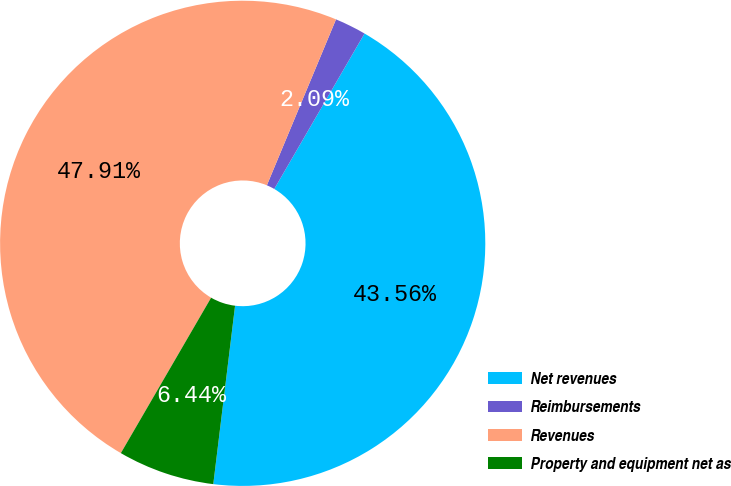<chart> <loc_0><loc_0><loc_500><loc_500><pie_chart><fcel>Net revenues<fcel>Reimbursements<fcel>Revenues<fcel>Property and equipment net as<nl><fcel>43.56%<fcel>2.09%<fcel>47.91%<fcel>6.44%<nl></chart> 